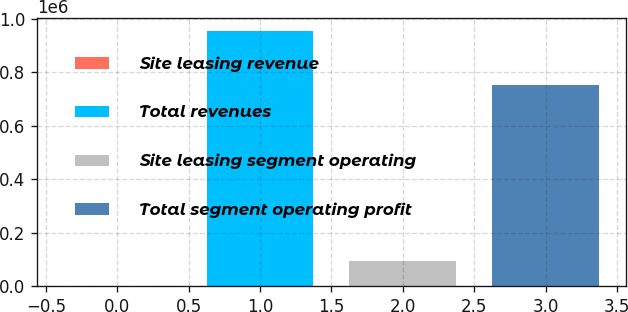Convert chart to OTSL. <chart><loc_0><loc_0><loc_500><loc_500><bar_chart><fcel>Site leasing revenue<fcel>Total revenues<fcel>Site leasing segment operating<fcel>Total segment operating profit<nl><fcel>88.7<fcel>954084<fcel>95488.2<fcel>752543<nl></chart> 